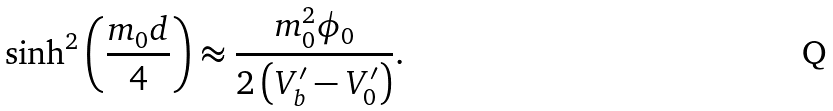Convert formula to latex. <formula><loc_0><loc_0><loc_500><loc_500>\sinh ^ { 2 } \left ( \frac { m _ { 0 } d } { 4 } \right ) \approx \frac { m _ { 0 } ^ { 2 } \phi _ { 0 } } { 2 \left ( V ^ { \prime } _ { b } - V ^ { \prime } _ { 0 } \right ) } .</formula> 